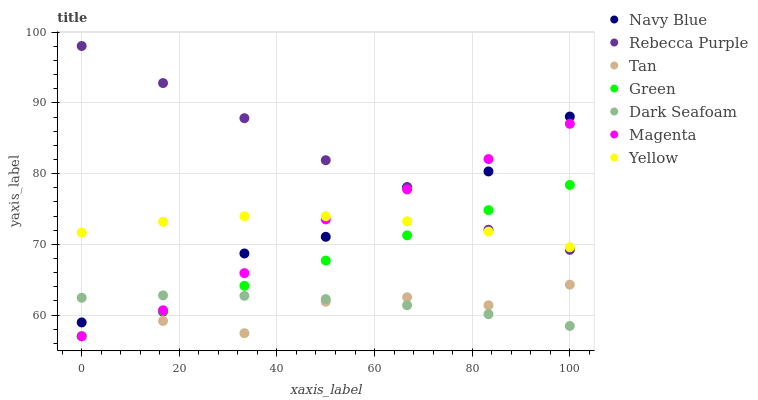Does Tan have the minimum area under the curve?
Answer yes or no. Yes. Does Rebecca Purple have the maximum area under the curve?
Answer yes or no. Yes. Does Yellow have the minimum area under the curve?
Answer yes or no. No. Does Yellow have the maximum area under the curve?
Answer yes or no. No. Is Green the smoothest?
Answer yes or no. Yes. Is Navy Blue the roughest?
Answer yes or no. Yes. Is Yellow the smoothest?
Answer yes or no. No. Is Yellow the roughest?
Answer yes or no. No. Does Green have the lowest value?
Answer yes or no. Yes. Does Dark Seafoam have the lowest value?
Answer yes or no. No. Does Rebecca Purple have the highest value?
Answer yes or no. Yes. Does Yellow have the highest value?
Answer yes or no. No. Is Dark Seafoam less than Yellow?
Answer yes or no. Yes. Is Yellow greater than Dark Seafoam?
Answer yes or no. Yes. Does Yellow intersect Green?
Answer yes or no. Yes. Is Yellow less than Green?
Answer yes or no. No. Is Yellow greater than Green?
Answer yes or no. No. Does Dark Seafoam intersect Yellow?
Answer yes or no. No. 